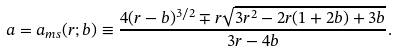Convert formula to latex. <formula><loc_0><loc_0><loc_500><loc_500>a = a _ { m s } ( r ; b ) \equiv \frac { 4 ( r - b ) ^ { 3 / 2 } \mp r \sqrt { 3 r ^ { 2 } - 2 r ( 1 + 2 b ) + 3 b } } { 3 r - 4 b } .</formula> 